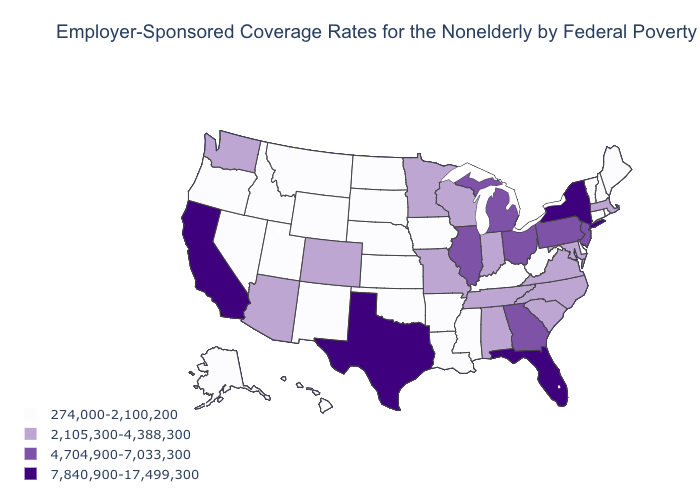Does Mississippi have a lower value than Maryland?
Keep it brief. Yes. What is the value of Missouri?
Quick response, please. 2,105,300-4,388,300. Does Arizona have a lower value than Oklahoma?
Keep it brief. No. Is the legend a continuous bar?
Be succinct. No. Does New Jersey have the highest value in the Northeast?
Keep it brief. No. What is the highest value in the USA?
Short answer required. 7,840,900-17,499,300. Is the legend a continuous bar?
Give a very brief answer. No. Which states have the highest value in the USA?
Be succinct. California, Florida, New York, Texas. What is the lowest value in the USA?
Answer briefly. 274,000-2,100,200. Does North Dakota have the lowest value in the MidWest?
Keep it brief. Yes. Does Tennessee have the lowest value in the South?
Be succinct. No. What is the value of Delaware?
Keep it brief. 274,000-2,100,200. Name the states that have a value in the range 2,105,300-4,388,300?
Give a very brief answer. Alabama, Arizona, Colorado, Indiana, Maryland, Massachusetts, Minnesota, Missouri, North Carolina, South Carolina, Tennessee, Virginia, Washington, Wisconsin. Does Arizona have a higher value than Georgia?
Short answer required. No. Among the states that border Oregon , does Washington have the lowest value?
Quick response, please. No. 